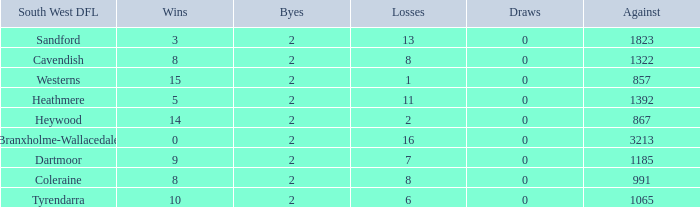Which Losses have a South West DFL of branxholme-wallacedale, and less than 2 Byes? None. 